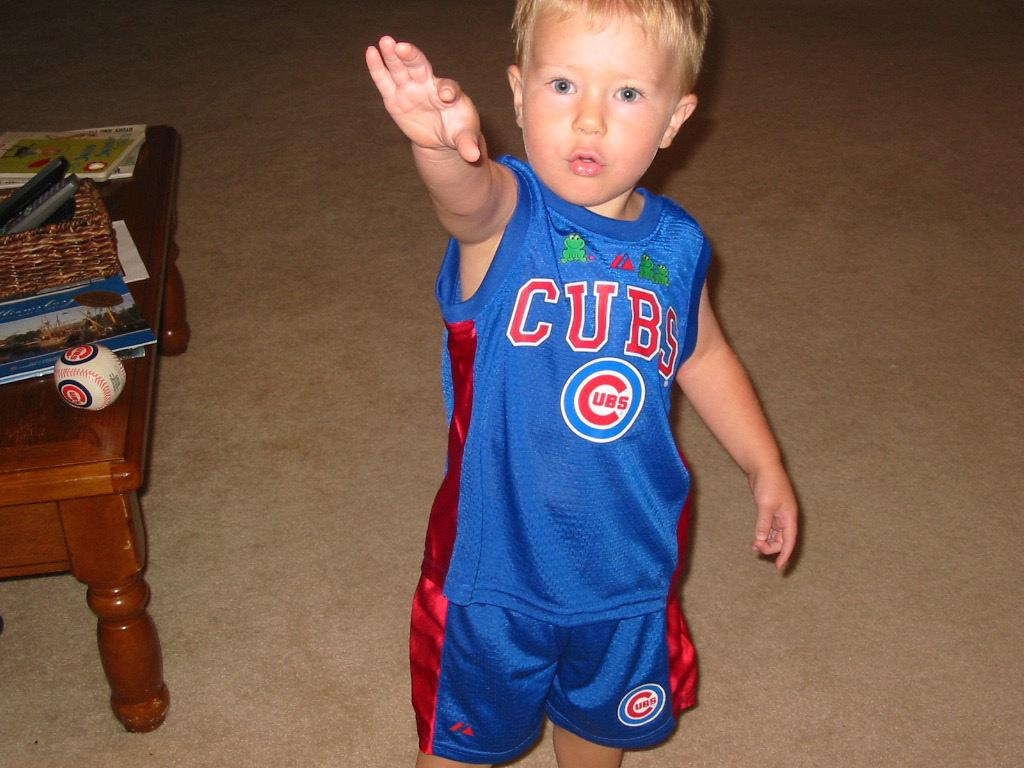<image>
Summarize the visual content of the image. A boy has a shirt with the Cubs logo on it. 